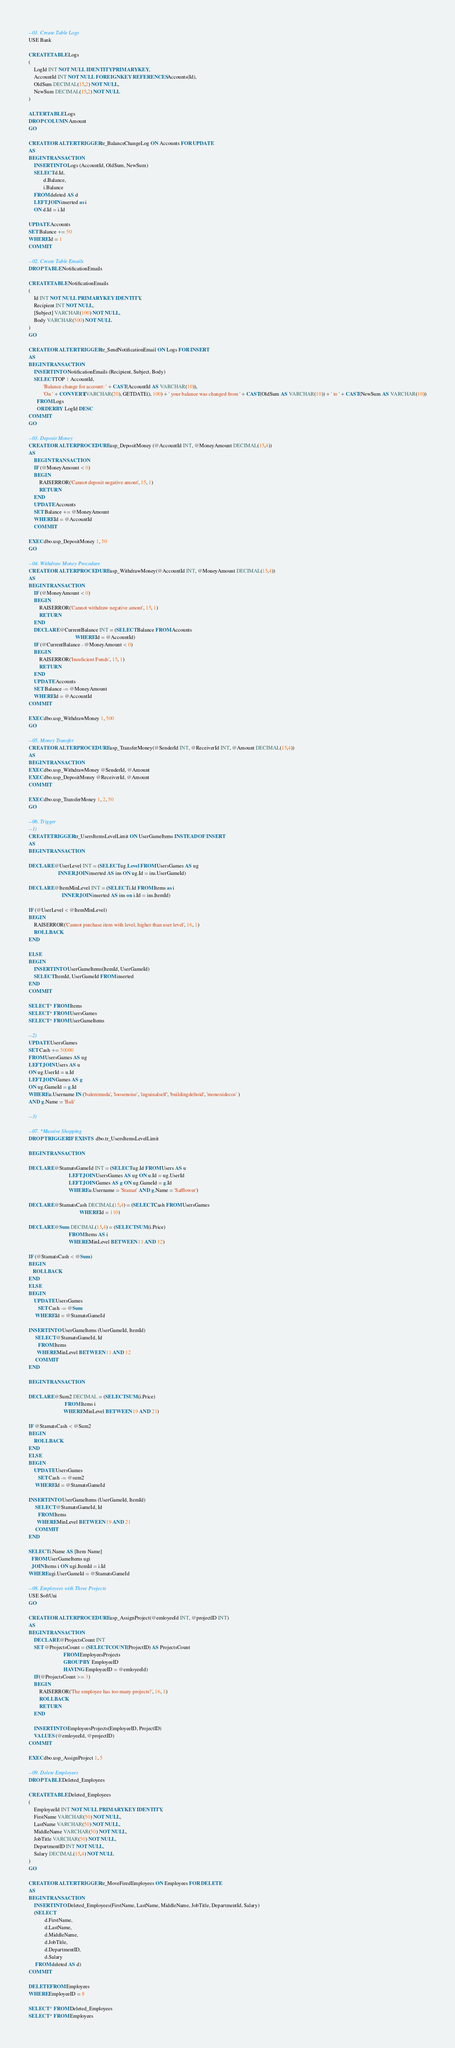<code> <loc_0><loc_0><loc_500><loc_500><_SQL_>--01. Create Table Logs
USE Bank

CREATE TABLE Logs
(
	LogId INT NOT NULL IDENTITY PRIMARY KEY,
	AccountId INT NOT NULL FOREIGN KEY REFERENCES Accounts(Id),
	OldSum DECIMAL(15,2) NOT NULL,
	NewSum DECIMAL(15,2) NOT NULL
)

ALTER TABLE Logs
DROP COLUMN Amount
GO

CREATE OR ALTER TRIGGER tr_BalanceChangeLog ON Accounts FOR UPDATE
AS 
BEGIN TRANSACTION
	INSERT INTO Logs (AccountId, OldSum, NewSum)
	SELECT d.Id, 
		   d.Balance, 
		   i.Balance
	FROM deleted AS d
	LEFT JOIN inserted as i
	ON d.Id = i.Id

UPDATE Accounts
SET Balance += 50
WHERE Id = 1
COMMIT

--02. Create Table Emails
DROP TABLE NotificationEmails

CREATE TABLE NotificationEmails
(
	Id INT NOT NULL PRIMARY KEY IDENTITY, 
	Recipient INT NOT NULL, 
	[Subject] VARCHAR(100) NOT NULL, 
	Body VARCHAR(500) NOT NULL
)
GO

CREATE OR ALTER TRIGGER tr_SendNotificationEmail ON Logs FOR INSERT
AS
BEGIN TRANSACTION
	INSERT INTO NotificationEmails (Recipient, Subject, Body)
	SELECT TOP 1 AccountId, 
		   'Balance change for account: ' + CAST(AccountId AS VARCHAR(10)),
		   'On ' + CONVERT(VARCHAR(20), GETDATE(), 100) + ' your balance was changed from ' + CAST(OldSum AS VARCHAR(10)) + ' to ' + CAST(NewSum AS VARCHAR(10))
	  FROM Logs
	  ORDER BY LogId DESC
COMMIT
GO

--03. Deposit Money
CREATE OR ALTER PROCEDURE usp_DepositMoney (@AccountId INT, @MoneyAmount DECIMAL(15,4)) 
AS
	BEGIN TRANSACTION
	IF (@MoneyAmount < 0)
	BEGIN
		RAISERROR('Cannot deposit negative amont', 15, 1)
		RETURN
	END
	UPDATE Accounts
	SET Balance += @MoneyAmount
	WHERE Id = @AccountId
	COMMIT

EXEC dbo.usp_DepositMoney 1, 50
GO

--04. Withdraw Money Procedure
CREATE OR ALTER PROCEDURE usp_WithdrawMoney(@AccountId INT, @MoneyAmount DECIMAL(15,4)) 
AS
BEGIN TRANSACTION
	IF (@MoneyAmount < 0)
	BEGIN
		RAISERROR('Cannot withdraw negative amont', 15, 1)
		RETURN
	END
	DECLARE @CurrentBalance INT = (SELECT Balance FROM Accounts 
								   WHERE Id = @AccountId)
	IF (@CurrentBalance - @MoneyAmount < 0)
	BEGIN
		RAISERROR('Insuficient Funds', 15, 1)
		RETURN
	END
	UPDATE Accounts
	SET Balance -= @MoneyAmount
	WHERE Id = @AccountId
COMMIT

EXEC dbo.usp_WithdrawMoney 1, 500
GO

--05. Money Transfer
CREATE OR ALTER PROCEDURE usp_TransferMoney(@SenderId INT, @ReceiverId INT, @Amount DECIMAL(15,4)) 
AS
BEGIN TRANSACTION 
EXEC dbo.usp_WithdrawMoney @SenderId, @Amount
EXEC dbo.usp_DepositMoney @ReceiverId, @Amount
COMMIT

EXEC dbo.usp_TransferMoney 1, 2, 50
GO

--06. Trigger
--1)
CREATE TRIGGER tr_UsersItemsLevelLimit ON UserGameItems INSTEAD OF INSERT
AS
BEGIN TRANSACTION

DECLARE @UserLevel INT = (SELECT ug.Level FROM UsersGames AS ug
					  INNER JOIN inserted AS ins ON ug.Id = ins.UserGameId)

DECLARE @ItemMinLevel INT = (SELECT i.Id FROM Items as i
						 INNER JOIN inserted AS ins on i.Id = ins.ItemId)

IF (@UserLevel < @ItemMinLevel)
BEGIN
	RAISERROR('Cannot purchase item with level, higher than user level', 16, 1)
	ROLLBACK
END

ELSE
BEGIN
	INSERT INTO UserGameItems(ItemId, UserGameId)
	SELECT ItemId, UserGameId FROM inserted
END
COMMIT

SELECT * FROM Items
SELECT * FROM UsersGames
SELECT * FROM UserGameItems

--2)
UPDATE UsersGames 
SET Cash += 50000
FROM UsersGames AS ug
LEFT JOIN Users AS u
ON ug.UserId = u.Id
LEFT JOIN Games AS g
ON ug.GameId = g.Id
WHERE u.Username IN ('baleremuda', 'loosenoise', 'inguinalself', 'buildingdeltoid', 'monoxidecos' )
AND g.Name = 'Bali'

--3)

--07. *Massive Shopping
DROP TRIGGER IF EXISTS  dbo.tr_UsersItemsLevelLimit

BEGIN TRANSACTION

DECLARE @StamatsGameId INT = (SELECT ug.Id FROM Users AS u
						      LEFT JOIN UsersGames AS ug ON u.Id = ug.UserId
						      LEFT JOIN Games AS g ON ug.GameId = g.Id
						      WHERE u.Username = 'Stamat' AND g.Name = 'Safflower')

DECLARE @StamatsCash DECIMAL(15,4) = (SELECT Cash FROM UsersGames 
									  WHERE Id = 110)

DECLARE @Sum DECIMAL(15,4) = (SELECT SUM(i.Price)
					          FROM Items AS i
						      WHERE MinLevel BETWEEN 11 AND 12)

IF (@StamatsCash < @Sum)
BEGIN
   ROLLBACK
END
ELSE 
BEGIN
	UPDATE UsersGames
	   SET Cash -= @Sum
	 WHERE Id = @StamatsGameId

INSERT INTO UserGameItems (UserGameId, ItemId)
	 SELECT @StamatsGameId, Id 
	   FROM Items 
	  WHERE MinLevel BETWEEN 11 AND 12
	 COMMIT
END

BEGIN TRANSACTION

DECLARE @Sum2 DECIMAL = (SELECT SUM(i.Price)
						   FROM Items i
						  WHERE MinLevel BETWEEN 19 AND 21)

IF @StamatsCash < @Sum2
BEGIN
	ROLLBACK
END
ELSE 
BEGIN
	UPDATE UsersGames
	   SET Cash -= @sum2
	 WHERE Id = @StamatsGameId

INSERT INTO UserGameItems (UserGameId, ItemId)
     SELECT @StamatsGameId, Id 
	   FROM Items 
	  WHERE MinLevel BETWEEN 19 AND 21
	 COMMIT
END

SELECT i.Name AS [Item Name] 
  FROM UserGameItems ugi
  JOIN Items i ON ugi.ItemId = i.Id
WHERE ugi.UserGameId = @StamatsGameId

--08. Employees with Three Projects
USE SoftUni
GO

CREATE OR ALTER PROCEDURE usp_AssignProject(@emloyeeId INT, @projectID INT) 
AS
BEGIN TRANSACTION
	DECLARE @ProjectsCount INT
	SET @ProjectsCount = (SELECT COUNT(ProjectID) AS ProjectsCount
						  FROM EmployeesProjects
						  GROUP BY EmployeeID
						  HAVING EmployeeID = @emloyeeId)
	IF(@ProjectsCount >= 3)
	BEGIN
		RAISERROR('The employee has too many projects!', 16, 1)
		ROLLBACK
		RETURN
	END

	INSERT INTO EmployeesProjects(EmployeeID, ProjectID)
	VALUES (@emloyeeId, @projectID)
COMMIT

EXEC dbo.usp_AssignProject 1, 5

--09. Delete Employees
DROP TABLE Deleted_Employees

CREATE TABLE Deleted_Employees
(
	EmployeeId INT NOT NULL PRIMARY KEY IDENTITY, 
	FirstName VARCHAR(50) NOT NULL,
	LastName VARCHAR(50) NOT NULL,
	MiddleName VARCHAR(50) NOT NULL,
	JobTitle VARCHAR(50) NOT NULL,
	DepartmentID INT NOT NULL,
	Salary DECIMAL(15,4) NOT NULL
) 
GO

CREATE OR ALTER TRIGGER tr_MoveFiredEmployees ON Employees FOR DELETE
AS
BEGIN TRANSACTION
	INSERT INTO Deleted_Employees(FirstName, LastName, MiddleName, JobTitle, DepartmentId, Salary)
	(SELECT 
			d.FirstName,
			d.LastName,
			d.MiddleName,
			d.JobTitle,
			d.DepartmentID,
			d.Salary
	 FROM deleted AS d)
COMMIT

DELETE FROM Employees
WHERE EmployeeID = 8

SELECT * FROM Deleted_Employees
SELECT * FROM Employees</code> 